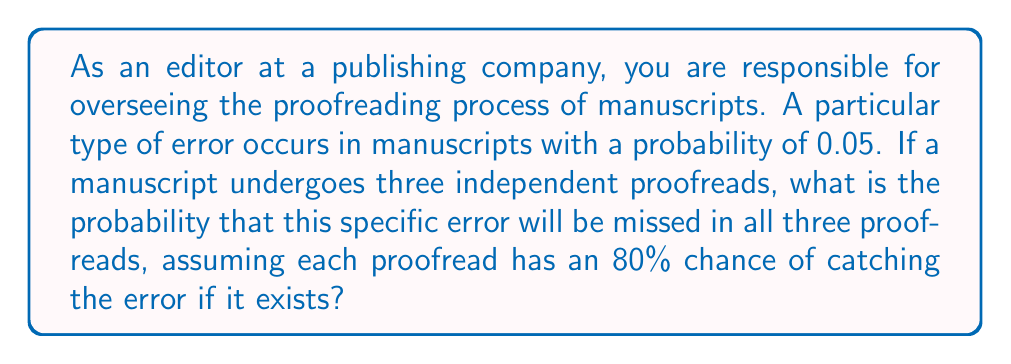Give your solution to this math problem. Let's approach this step-by-step:

1) First, we need to calculate the probability of missing the error in a single proofread:
   - The probability of catching the error is 0.80 (80%)
   - Therefore, the probability of missing the error is $1 - 0.80 = 0.20$ (20%)

2) Now, we need to calculate the probability of missing the error in all three proofreads:
   - This is an example of independent events, so we multiply the probabilities
   - The probability is $(0.20)^3 = 0.008$

3) However, this is the probability of missing the error if it exists. We need to account for the probability that the error exists in the first place:
   - The probability of the error existing is 0.05 (5%)

4) To get the final probability, we multiply the probability of the error existing by the probability of missing it in all three proofreads:

   $$ P(\text{error exists and is missed}) = P(\text{error exists}) \times P(\text{error is missed in all proofreads}) $$
   $$ = 0.05 \times 0.008 = 0.0004 $$

Therefore, the probability of this specific error existing in the manuscript and being missed in all three proofreads is 0.0004 or 0.04%.
Answer: $0.0004$ or $0.04\%$ 